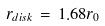Convert formula to latex. <formula><loc_0><loc_0><loc_500><loc_500>r _ { d i s k } \, = \, 1 . 6 8 r _ { 0 }</formula> 